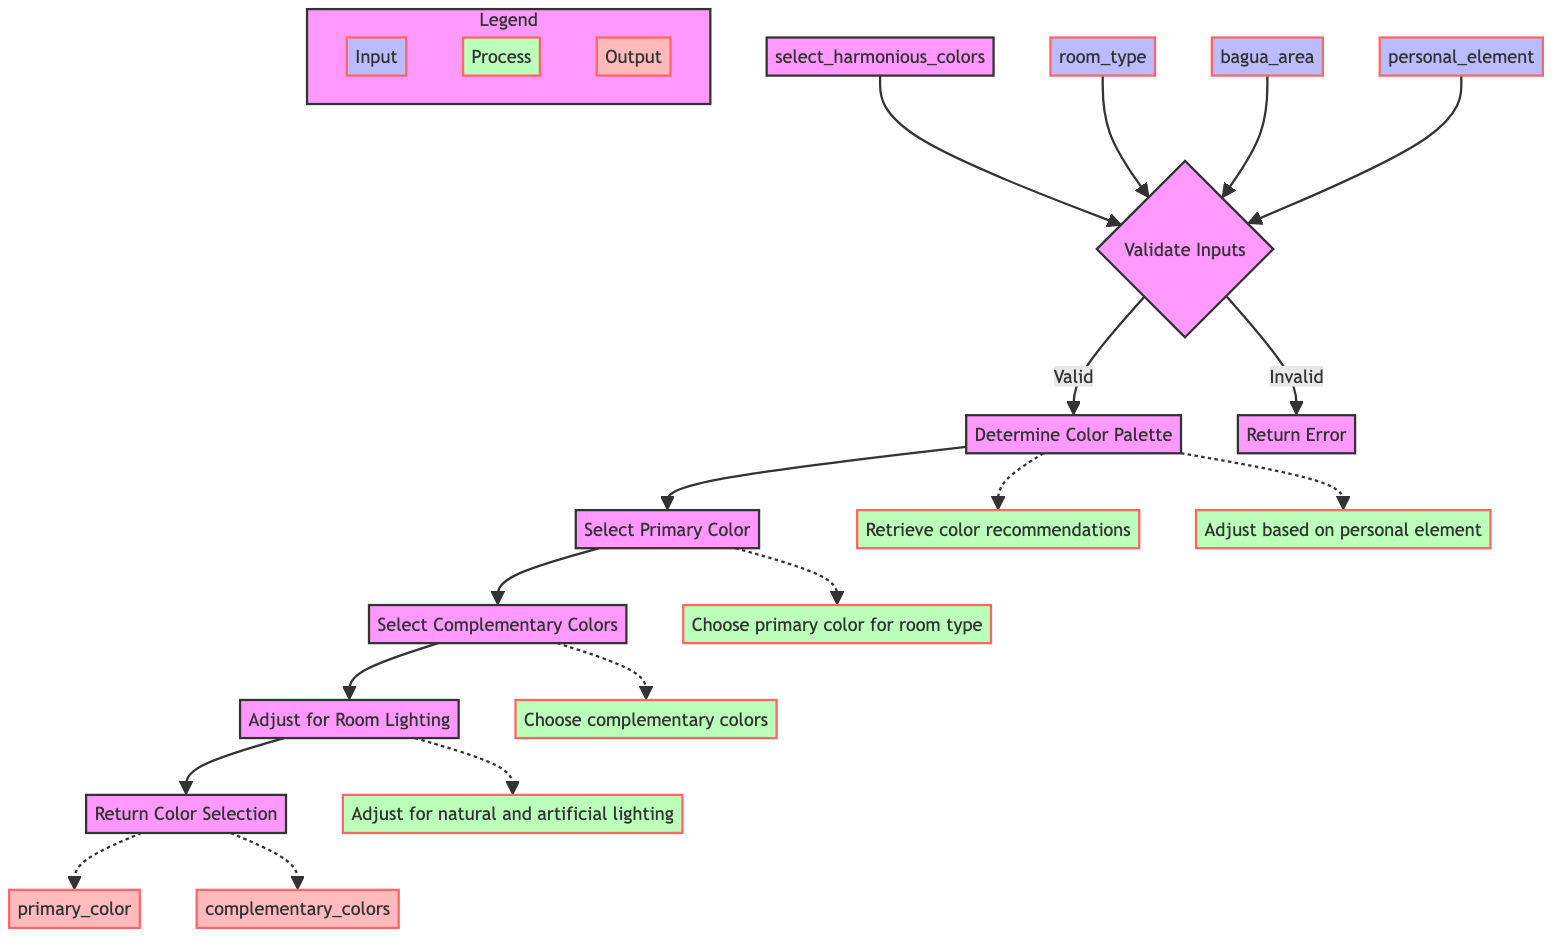What is the name of the function represented in the diagram? The diagram represents the function "select_harmonious_colors" as indicated at the top.
Answer: select_harmonious_colors How many input parameters does the function have? The diagram lists three input parameters: room_type, bagua_area, and personal_element.
Answer: 3 What step follows after "Validate Inputs"? After "Validate Inputs," the next step is "Determine Color Palette."
Answer: Determine Color Palette What are the outputs of the function? The outputs specified in the diagram are "primary_color" and "complementary_colors."
Answer: primary_color and complementary_colors If inputs are invalid, what is the next step? If the inputs are invalid, the next action in the diagram is to "Return Error."
Answer: Return Error What adjustment is made after selecting complementary colors? After selecting complementary colors, the step "Adjust for Room Lighting" is performed next.
Answer: Adjust for Room Lighting How is the primary color selected? The primary color is chosen based on the room type from the color palette. This information is indicated in the "Select Primary Color" step.
Answer: Choose a primary color for room type Describe the relationship between "Determine Color Palette" and "Select Primary Color." "Select Primary Color" is the step that follows "Determine Color Palette," indicating that the color palette must first be established before selecting a primary color.
Answer: Select Primary Color follows Determine Color Palette Which input is related to the room's purpose? The input related to the room's purpose is "room_type." It defines the kind of room being designed.
Answer: room_type 